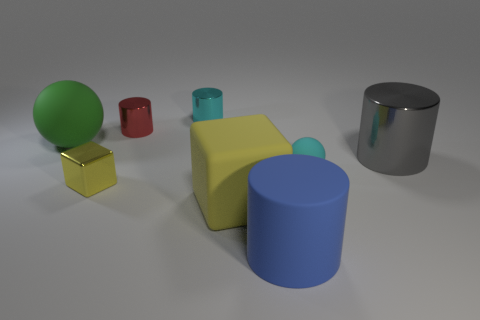There is a small object right of the blue matte cylinder; what is its color?
Keep it short and to the point. Cyan. What is the shape of the shiny thing that is the same color as the rubber cube?
Your response must be concise. Cube. The tiny cyan object in front of the big metallic thing has what shape?
Keep it short and to the point. Sphere. How many purple things are matte objects or big matte cubes?
Give a very brief answer. 0. Does the large gray object have the same material as the small cyan cylinder?
Provide a short and direct response. Yes. How many tiny cylinders are right of the large green thing?
Keep it short and to the point. 2. The object that is in front of the gray thing and right of the blue rubber thing is made of what material?
Ensure brevity in your answer.  Rubber. How many cylinders are either yellow matte things or large blue objects?
Give a very brief answer. 1. There is a blue thing that is the same shape as the small cyan metallic object; what is its material?
Provide a succinct answer. Rubber. There is a blue cylinder that is the same material as the small cyan ball; what size is it?
Ensure brevity in your answer.  Large. 